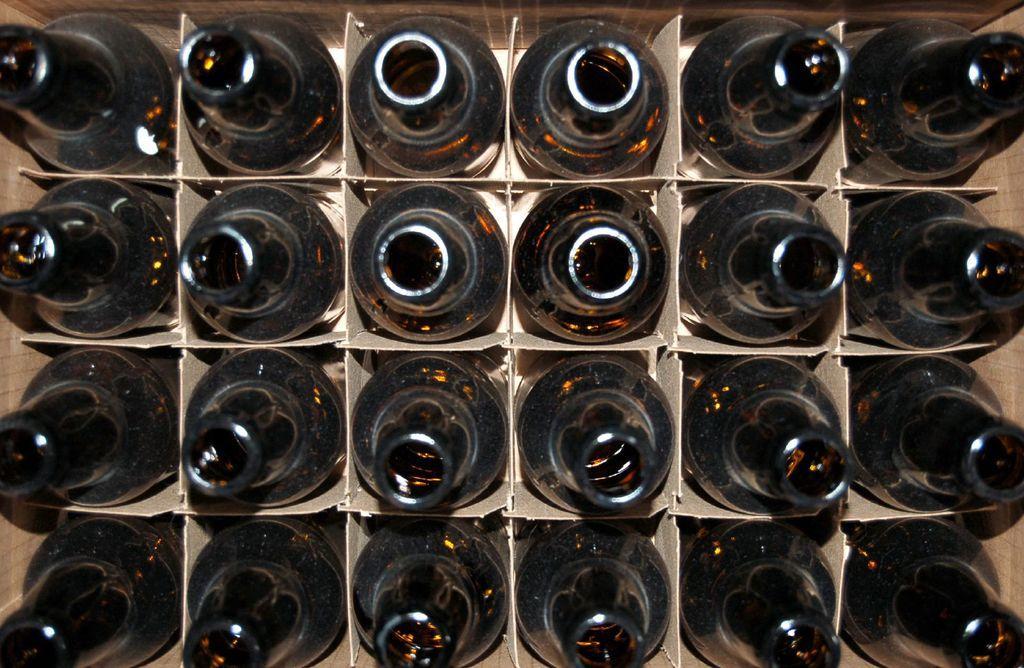In one or two sentences, can you explain what this image depicts? I could see number of bottles arranged in a row in a cardboard box. They are black in color. 